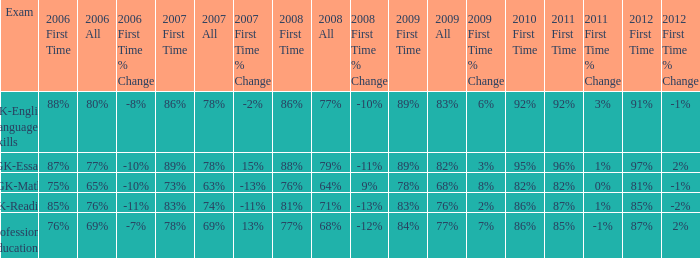What is the percentage for 2008 First time when in 2006 it was 85%? 81%. 